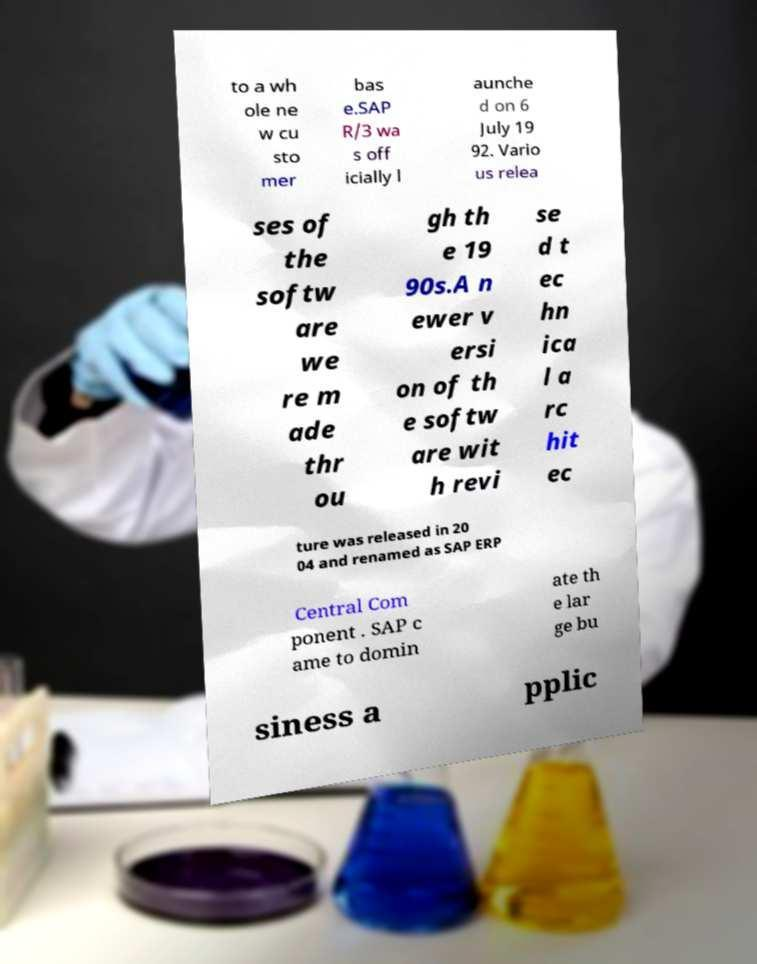Please read and relay the text visible in this image. What does it say? to a wh ole ne w cu sto mer bas e.SAP R/3 wa s off icially l aunche d on 6 July 19 92. Vario us relea ses of the softw are we re m ade thr ou gh th e 19 90s.A n ewer v ersi on of th e softw are wit h revi se d t ec hn ica l a rc hit ec ture was released in 20 04 and renamed as SAP ERP Central Com ponent . SAP c ame to domin ate th e lar ge bu siness a pplic 